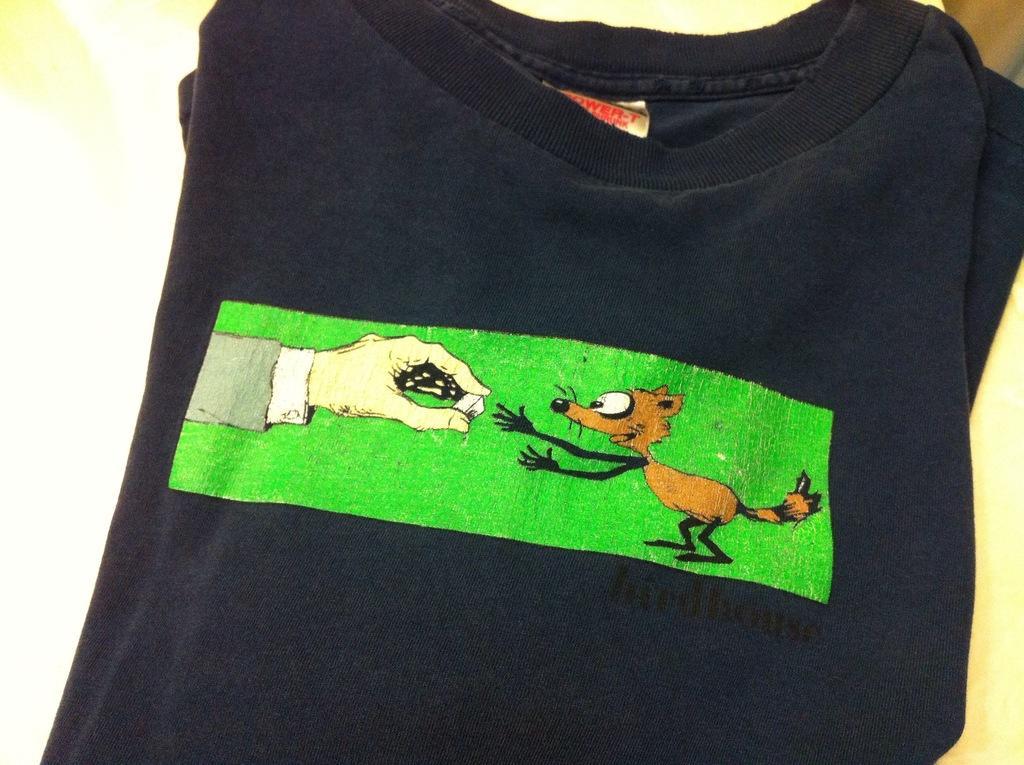How would you summarize this image in a sentence or two? In this image we can see a T-shirt. There is some print on the T-shirt. 